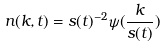Convert formula to latex. <formula><loc_0><loc_0><loc_500><loc_500>n ( k , t ) = s ( t ) ^ { - 2 } \psi ( \frac { k } { s ( t ) } )</formula> 